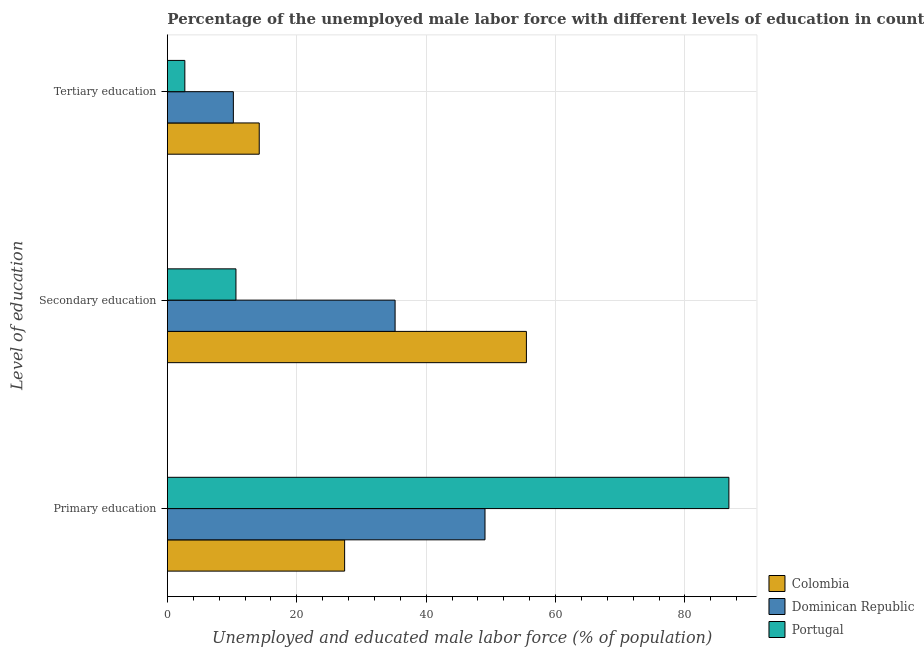How many different coloured bars are there?
Make the answer very short. 3. How many groups of bars are there?
Your response must be concise. 3. Are the number of bars per tick equal to the number of legend labels?
Offer a terse response. Yes. How many bars are there on the 3rd tick from the top?
Give a very brief answer. 3. What is the label of the 1st group of bars from the top?
Make the answer very short. Tertiary education. What is the percentage of male labor force who received primary education in Dominican Republic?
Your response must be concise. 49.1. Across all countries, what is the maximum percentage of male labor force who received tertiary education?
Give a very brief answer. 14.2. Across all countries, what is the minimum percentage of male labor force who received secondary education?
Make the answer very short. 10.6. What is the total percentage of male labor force who received secondary education in the graph?
Ensure brevity in your answer.  101.3. What is the difference between the percentage of male labor force who received primary education in Portugal and that in Dominican Republic?
Give a very brief answer. 37.7. What is the difference between the percentage of male labor force who received primary education in Colombia and the percentage of male labor force who received tertiary education in Portugal?
Offer a terse response. 24.7. What is the average percentage of male labor force who received primary education per country?
Your response must be concise. 54.43. What is the difference between the percentage of male labor force who received secondary education and percentage of male labor force who received tertiary education in Portugal?
Make the answer very short. 7.9. What is the ratio of the percentage of male labor force who received secondary education in Colombia to that in Portugal?
Offer a terse response. 5.24. Is the difference between the percentage of male labor force who received secondary education in Portugal and Dominican Republic greater than the difference between the percentage of male labor force who received tertiary education in Portugal and Dominican Republic?
Offer a very short reply. No. What is the difference between the highest and the lowest percentage of male labor force who received primary education?
Offer a very short reply. 59.4. In how many countries, is the percentage of male labor force who received primary education greater than the average percentage of male labor force who received primary education taken over all countries?
Your response must be concise. 1. Is the sum of the percentage of male labor force who received tertiary education in Colombia and Portugal greater than the maximum percentage of male labor force who received primary education across all countries?
Offer a very short reply. No. What does the 3rd bar from the bottom in Tertiary education represents?
Keep it short and to the point. Portugal. Is it the case that in every country, the sum of the percentage of male labor force who received primary education and percentage of male labor force who received secondary education is greater than the percentage of male labor force who received tertiary education?
Your answer should be very brief. Yes. How many bars are there?
Your answer should be compact. 9. Are all the bars in the graph horizontal?
Ensure brevity in your answer.  Yes. How many countries are there in the graph?
Keep it short and to the point. 3. What is the difference between two consecutive major ticks on the X-axis?
Your answer should be very brief. 20. Where does the legend appear in the graph?
Ensure brevity in your answer.  Bottom right. How are the legend labels stacked?
Offer a very short reply. Vertical. What is the title of the graph?
Provide a short and direct response. Percentage of the unemployed male labor force with different levels of education in countries. Does "Ghana" appear as one of the legend labels in the graph?
Offer a very short reply. No. What is the label or title of the X-axis?
Provide a succinct answer. Unemployed and educated male labor force (% of population). What is the label or title of the Y-axis?
Give a very brief answer. Level of education. What is the Unemployed and educated male labor force (% of population) in Colombia in Primary education?
Your response must be concise. 27.4. What is the Unemployed and educated male labor force (% of population) of Dominican Republic in Primary education?
Offer a terse response. 49.1. What is the Unemployed and educated male labor force (% of population) in Portugal in Primary education?
Your answer should be compact. 86.8. What is the Unemployed and educated male labor force (% of population) of Colombia in Secondary education?
Offer a very short reply. 55.5. What is the Unemployed and educated male labor force (% of population) in Dominican Republic in Secondary education?
Keep it short and to the point. 35.2. What is the Unemployed and educated male labor force (% of population) of Portugal in Secondary education?
Keep it short and to the point. 10.6. What is the Unemployed and educated male labor force (% of population) of Colombia in Tertiary education?
Offer a very short reply. 14.2. What is the Unemployed and educated male labor force (% of population) in Dominican Republic in Tertiary education?
Your response must be concise. 10.2. What is the Unemployed and educated male labor force (% of population) of Portugal in Tertiary education?
Keep it short and to the point. 2.7. Across all Level of education, what is the maximum Unemployed and educated male labor force (% of population) of Colombia?
Your answer should be very brief. 55.5. Across all Level of education, what is the maximum Unemployed and educated male labor force (% of population) in Dominican Republic?
Provide a short and direct response. 49.1. Across all Level of education, what is the maximum Unemployed and educated male labor force (% of population) of Portugal?
Offer a terse response. 86.8. Across all Level of education, what is the minimum Unemployed and educated male labor force (% of population) of Colombia?
Your answer should be compact. 14.2. Across all Level of education, what is the minimum Unemployed and educated male labor force (% of population) of Dominican Republic?
Keep it short and to the point. 10.2. Across all Level of education, what is the minimum Unemployed and educated male labor force (% of population) in Portugal?
Provide a succinct answer. 2.7. What is the total Unemployed and educated male labor force (% of population) in Colombia in the graph?
Your answer should be compact. 97.1. What is the total Unemployed and educated male labor force (% of population) in Dominican Republic in the graph?
Offer a very short reply. 94.5. What is the total Unemployed and educated male labor force (% of population) of Portugal in the graph?
Your answer should be compact. 100.1. What is the difference between the Unemployed and educated male labor force (% of population) in Colombia in Primary education and that in Secondary education?
Provide a succinct answer. -28.1. What is the difference between the Unemployed and educated male labor force (% of population) of Dominican Republic in Primary education and that in Secondary education?
Your response must be concise. 13.9. What is the difference between the Unemployed and educated male labor force (% of population) of Portugal in Primary education and that in Secondary education?
Provide a succinct answer. 76.2. What is the difference between the Unemployed and educated male labor force (% of population) of Colombia in Primary education and that in Tertiary education?
Ensure brevity in your answer.  13.2. What is the difference between the Unemployed and educated male labor force (% of population) in Dominican Republic in Primary education and that in Tertiary education?
Your response must be concise. 38.9. What is the difference between the Unemployed and educated male labor force (% of population) of Portugal in Primary education and that in Tertiary education?
Provide a short and direct response. 84.1. What is the difference between the Unemployed and educated male labor force (% of population) in Colombia in Secondary education and that in Tertiary education?
Your response must be concise. 41.3. What is the difference between the Unemployed and educated male labor force (% of population) in Dominican Republic in Secondary education and that in Tertiary education?
Keep it short and to the point. 25. What is the difference between the Unemployed and educated male labor force (% of population) of Colombia in Primary education and the Unemployed and educated male labor force (% of population) of Portugal in Secondary education?
Ensure brevity in your answer.  16.8. What is the difference between the Unemployed and educated male labor force (% of population) of Dominican Republic in Primary education and the Unemployed and educated male labor force (% of population) of Portugal in Secondary education?
Ensure brevity in your answer.  38.5. What is the difference between the Unemployed and educated male labor force (% of population) of Colombia in Primary education and the Unemployed and educated male labor force (% of population) of Dominican Republic in Tertiary education?
Offer a terse response. 17.2. What is the difference between the Unemployed and educated male labor force (% of population) of Colombia in Primary education and the Unemployed and educated male labor force (% of population) of Portugal in Tertiary education?
Offer a terse response. 24.7. What is the difference between the Unemployed and educated male labor force (% of population) in Dominican Republic in Primary education and the Unemployed and educated male labor force (% of population) in Portugal in Tertiary education?
Ensure brevity in your answer.  46.4. What is the difference between the Unemployed and educated male labor force (% of population) of Colombia in Secondary education and the Unemployed and educated male labor force (% of population) of Dominican Republic in Tertiary education?
Keep it short and to the point. 45.3. What is the difference between the Unemployed and educated male labor force (% of population) of Colombia in Secondary education and the Unemployed and educated male labor force (% of population) of Portugal in Tertiary education?
Offer a very short reply. 52.8. What is the difference between the Unemployed and educated male labor force (% of population) of Dominican Republic in Secondary education and the Unemployed and educated male labor force (% of population) of Portugal in Tertiary education?
Provide a succinct answer. 32.5. What is the average Unemployed and educated male labor force (% of population) of Colombia per Level of education?
Offer a terse response. 32.37. What is the average Unemployed and educated male labor force (% of population) of Dominican Republic per Level of education?
Offer a terse response. 31.5. What is the average Unemployed and educated male labor force (% of population) in Portugal per Level of education?
Your answer should be compact. 33.37. What is the difference between the Unemployed and educated male labor force (% of population) of Colombia and Unemployed and educated male labor force (% of population) of Dominican Republic in Primary education?
Provide a succinct answer. -21.7. What is the difference between the Unemployed and educated male labor force (% of population) of Colombia and Unemployed and educated male labor force (% of population) of Portugal in Primary education?
Your response must be concise. -59.4. What is the difference between the Unemployed and educated male labor force (% of population) of Dominican Republic and Unemployed and educated male labor force (% of population) of Portugal in Primary education?
Make the answer very short. -37.7. What is the difference between the Unemployed and educated male labor force (% of population) in Colombia and Unemployed and educated male labor force (% of population) in Dominican Republic in Secondary education?
Offer a very short reply. 20.3. What is the difference between the Unemployed and educated male labor force (% of population) in Colombia and Unemployed and educated male labor force (% of population) in Portugal in Secondary education?
Make the answer very short. 44.9. What is the difference between the Unemployed and educated male labor force (% of population) in Dominican Republic and Unemployed and educated male labor force (% of population) in Portugal in Secondary education?
Offer a very short reply. 24.6. What is the difference between the Unemployed and educated male labor force (% of population) in Colombia and Unemployed and educated male labor force (% of population) in Dominican Republic in Tertiary education?
Make the answer very short. 4. What is the difference between the Unemployed and educated male labor force (% of population) in Colombia and Unemployed and educated male labor force (% of population) in Portugal in Tertiary education?
Ensure brevity in your answer.  11.5. What is the difference between the Unemployed and educated male labor force (% of population) in Dominican Republic and Unemployed and educated male labor force (% of population) in Portugal in Tertiary education?
Provide a succinct answer. 7.5. What is the ratio of the Unemployed and educated male labor force (% of population) of Colombia in Primary education to that in Secondary education?
Provide a succinct answer. 0.49. What is the ratio of the Unemployed and educated male labor force (% of population) in Dominican Republic in Primary education to that in Secondary education?
Provide a short and direct response. 1.39. What is the ratio of the Unemployed and educated male labor force (% of population) of Portugal in Primary education to that in Secondary education?
Offer a terse response. 8.19. What is the ratio of the Unemployed and educated male labor force (% of population) in Colombia in Primary education to that in Tertiary education?
Your answer should be very brief. 1.93. What is the ratio of the Unemployed and educated male labor force (% of population) of Dominican Republic in Primary education to that in Tertiary education?
Provide a succinct answer. 4.81. What is the ratio of the Unemployed and educated male labor force (% of population) in Portugal in Primary education to that in Tertiary education?
Your answer should be compact. 32.15. What is the ratio of the Unemployed and educated male labor force (% of population) of Colombia in Secondary education to that in Tertiary education?
Provide a succinct answer. 3.91. What is the ratio of the Unemployed and educated male labor force (% of population) in Dominican Republic in Secondary education to that in Tertiary education?
Your answer should be very brief. 3.45. What is the ratio of the Unemployed and educated male labor force (% of population) of Portugal in Secondary education to that in Tertiary education?
Your answer should be very brief. 3.93. What is the difference between the highest and the second highest Unemployed and educated male labor force (% of population) in Colombia?
Ensure brevity in your answer.  28.1. What is the difference between the highest and the second highest Unemployed and educated male labor force (% of population) in Dominican Republic?
Provide a succinct answer. 13.9. What is the difference between the highest and the second highest Unemployed and educated male labor force (% of population) in Portugal?
Ensure brevity in your answer.  76.2. What is the difference between the highest and the lowest Unemployed and educated male labor force (% of population) of Colombia?
Keep it short and to the point. 41.3. What is the difference between the highest and the lowest Unemployed and educated male labor force (% of population) in Dominican Republic?
Keep it short and to the point. 38.9. What is the difference between the highest and the lowest Unemployed and educated male labor force (% of population) in Portugal?
Provide a succinct answer. 84.1. 